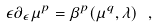Convert formula to latex. <formula><loc_0><loc_0><loc_500><loc_500>\epsilon \partial _ { \epsilon } \mu ^ { p } = \beta ^ { p } ( \mu ^ { q } , \lambda ) \ ,</formula> 